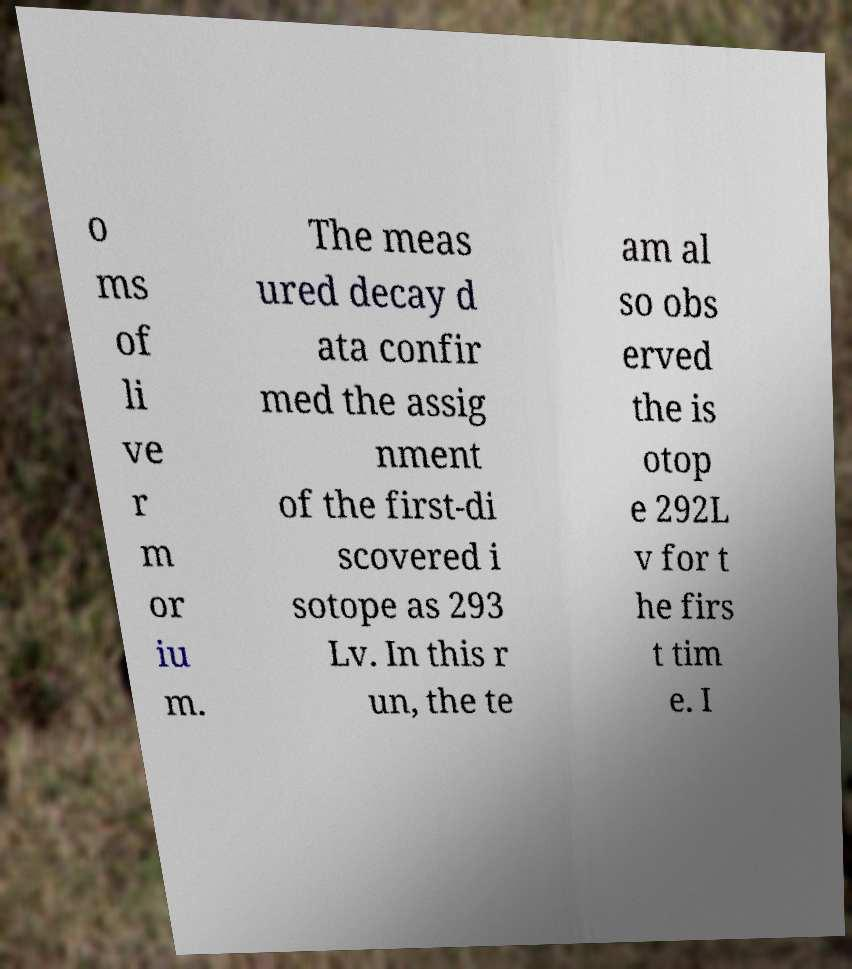Please identify and transcribe the text found in this image. o ms of li ve r m or iu m. The meas ured decay d ata confir med the assig nment of the first-di scovered i sotope as 293 Lv. In this r un, the te am al so obs erved the is otop e 292L v for t he firs t tim e. I 